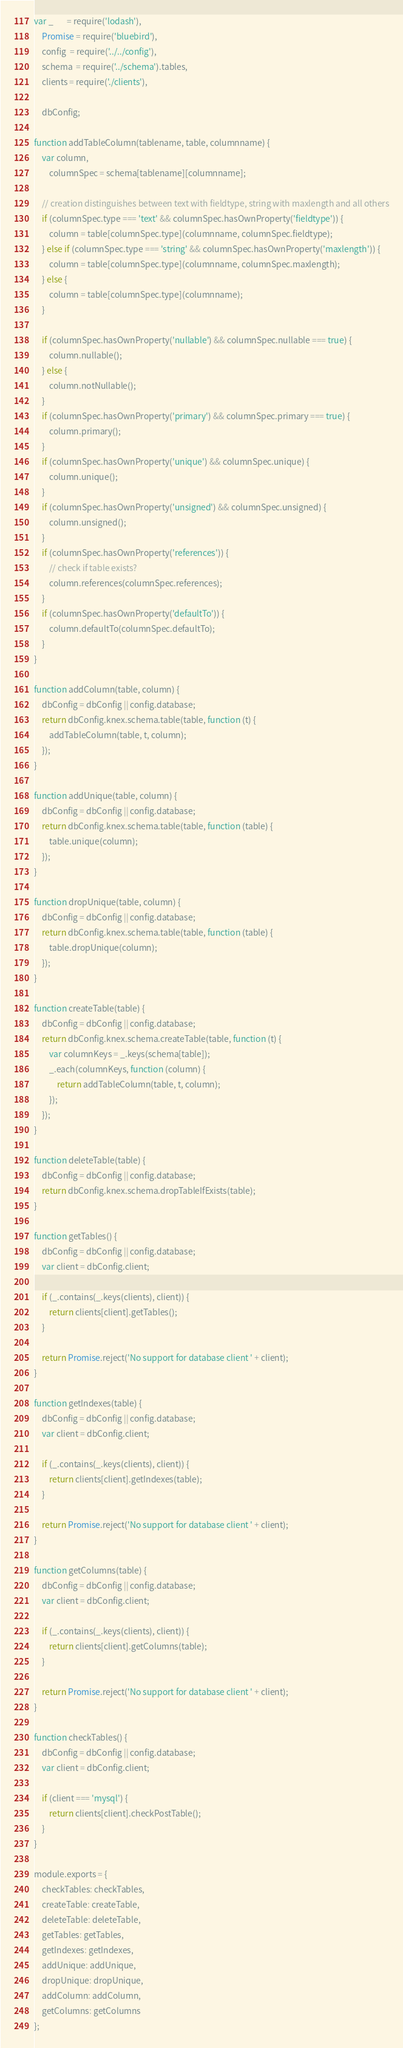Convert code to text. <code><loc_0><loc_0><loc_500><loc_500><_JavaScript_>var _       = require('lodash'),
    Promise = require('bluebird'),
    config  = require('../../config'),
    schema  = require('../schema').tables,
    clients = require('./clients'),

    dbConfig;

function addTableColumn(tablename, table, columnname) {
    var column,
        columnSpec = schema[tablename][columnname];

    // creation distinguishes between text with fieldtype, string with maxlength and all others
    if (columnSpec.type === 'text' && columnSpec.hasOwnProperty('fieldtype')) {
        column = table[columnSpec.type](columnname, columnSpec.fieldtype);
    } else if (columnSpec.type === 'string' && columnSpec.hasOwnProperty('maxlength')) {
        column = table[columnSpec.type](columnname, columnSpec.maxlength);
    } else {
        column = table[columnSpec.type](columnname);
    }

    if (columnSpec.hasOwnProperty('nullable') && columnSpec.nullable === true) {
        column.nullable();
    } else {
        column.notNullable();
    }
    if (columnSpec.hasOwnProperty('primary') && columnSpec.primary === true) {
        column.primary();
    }
    if (columnSpec.hasOwnProperty('unique') && columnSpec.unique) {
        column.unique();
    }
    if (columnSpec.hasOwnProperty('unsigned') && columnSpec.unsigned) {
        column.unsigned();
    }
    if (columnSpec.hasOwnProperty('references')) {
        // check if table exists?
        column.references(columnSpec.references);
    }
    if (columnSpec.hasOwnProperty('defaultTo')) {
        column.defaultTo(columnSpec.defaultTo);
    }
}

function addColumn(table, column) {
    dbConfig = dbConfig || config.database;
    return dbConfig.knex.schema.table(table, function (t) {
        addTableColumn(table, t, column);
    });
}

function addUnique(table, column) {
    dbConfig = dbConfig || config.database;
    return dbConfig.knex.schema.table(table, function (table) {
        table.unique(column);
    });
}

function dropUnique(table, column) {
    dbConfig = dbConfig || config.database;
    return dbConfig.knex.schema.table(table, function (table) {
        table.dropUnique(column);
    });
}

function createTable(table) {
    dbConfig = dbConfig || config.database;
    return dbConfig.knex.schema.createTable(table, function (t) {
        var columnKeys = _.keys(schema[table]);
        _.each(columnKeys, function (column) {
            return addTableColumn(table, t, column);
        });
    });
}

function deleteTable(table) {
    dbConfig = dbConfig || config.database;
    return dbConfig.knex.schema.dropTableIfExists(table);
}

function getTables() {
    dbConfig = dbConfig || config.database;
    var client = dbConfig.client;

    if (_.contains(_.keys(clients), client)) {
        return clients[client].getTables();
    }

    return Promise.reject('No support for database client ' + client);
}

function getIndexes(table) {
    dbConfig = dbConfig || config.database;
    var client = dbConfig.client;

    if (_.contains(_.keys(clients), client)) {
        return clients[client].getIndexes(table);
    }

    return Promise.reject('No support for database client ' + client);
}

function getColumns(table) {
    dbConfig = dbConfig || config.database;
    var client = dbConfig.client;

    if (_.contains(_.keys(clients), client)) {
        return clients[client].getColumns(table);
    }

    return Promise.reject('No support for database client ' + client);
}

function checkTables() {
    dbConfig = dbConfig || config.database;
    var client = dbConfig.client;

    if (client === 'mysql') {
        return clients[client].checkPostTable();
    }
}

module.exports = {
    checkTables: checkTables,
    createTable: createTable,
    deleteTable: deleteTable,
    getTables: getTables,
    getIndexes: getIndexes,
    addUnique: addUnique,
    dropUnique: dropUnique,
    addColumn: addColumn,
    getColumns: getColumns
};
</code> 